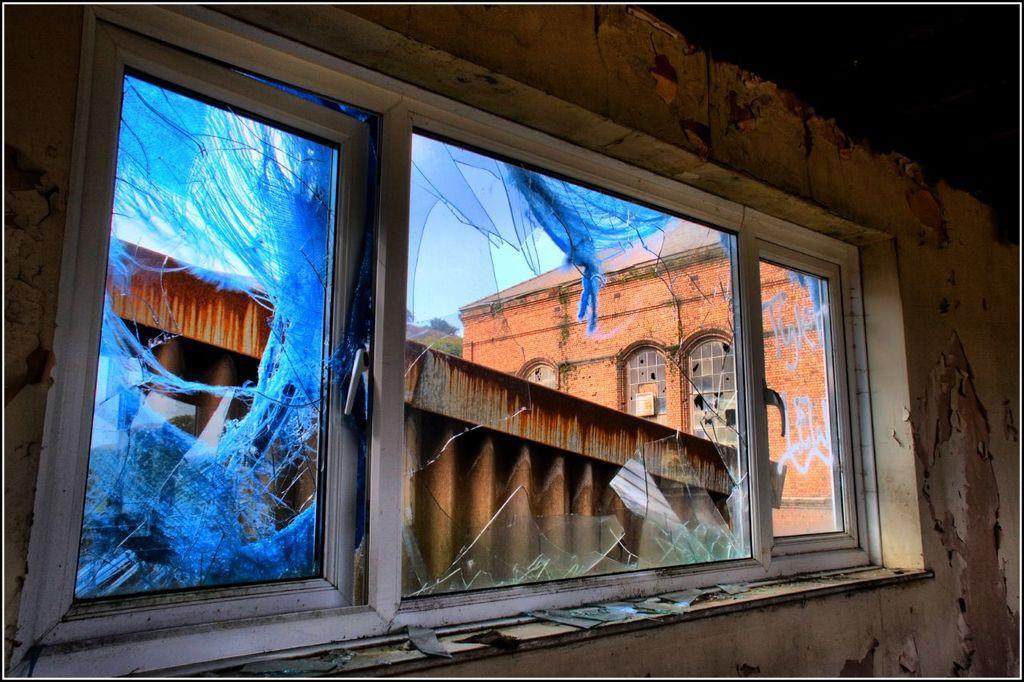Please provide a concise description of this image. In this picture there is a broken glass window. Behind there is a red color brick building. 